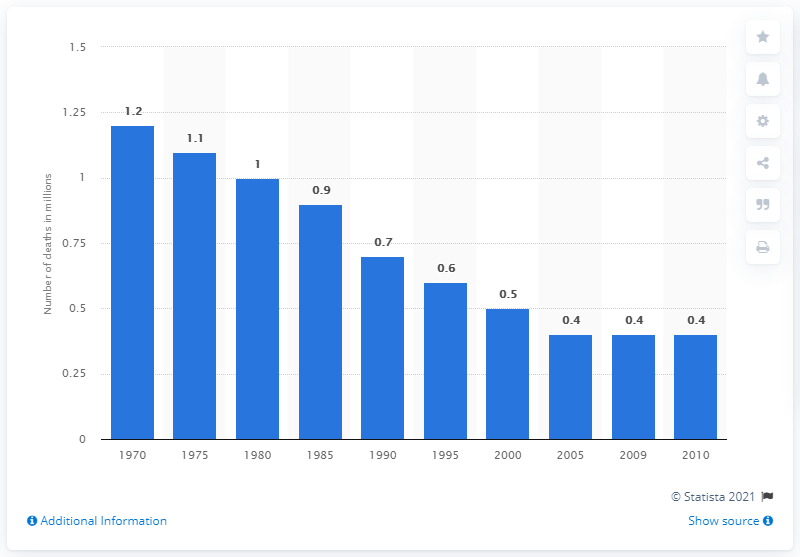Specify some key components in this picture. According to data from 2010, there were 0.4 child deaths. In 1970, the total number of child deaths was 1.2 million. 